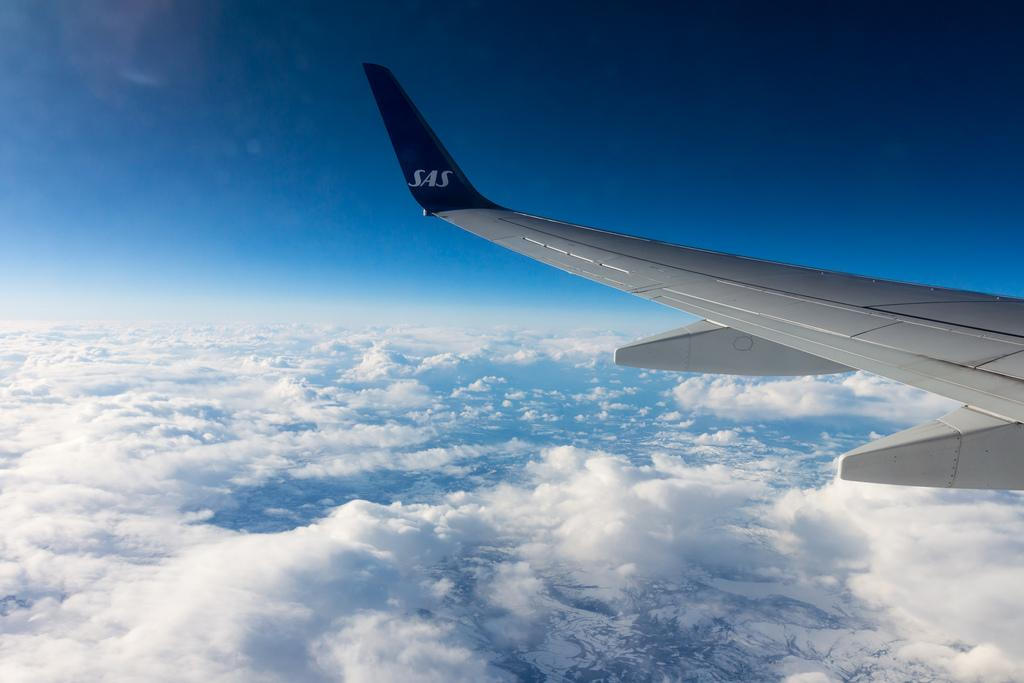What is the main subject of the image? The main subject of the image is an airplane. Where is the airplane located in the image? The airplane is in the air. What can be seen at the bottom of the image? There are clouds at the bottom of the image. What is visible at the top of the image? The sky is visible at the top of the image. What type of coil is being used by the passenger in the image? There is no passenger present in the image, and therefore no coil can be observed. 